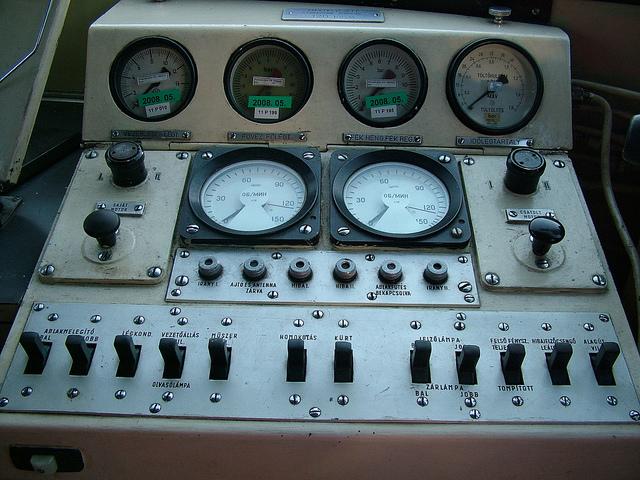What is the picture of?
Short answer required. Control panel. Who fixes the machine if it breaks?
Answer briefly. Mechanic. Is this a modern machine?
Short answer required. No. 